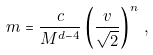Convert formula to latex. <formula><loc_0><loc_0><loc_500><loc_500>m = \frac { c } { M ^ { d - 4 } } \left ( \frac { v } { \sqrt { 2 } } \right ) ^ { n } \, ,</formula> 